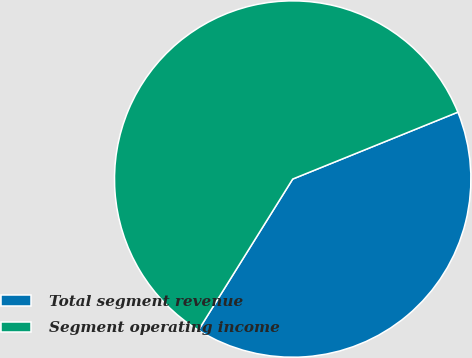<chart> <loc_0><loc_0><loc_500><loc_500><pie_chart><fcel>Total segment revenue<fcel>Segment operating income<nl><fcel>40.0%<fcel>60.0%<nl></chart> 